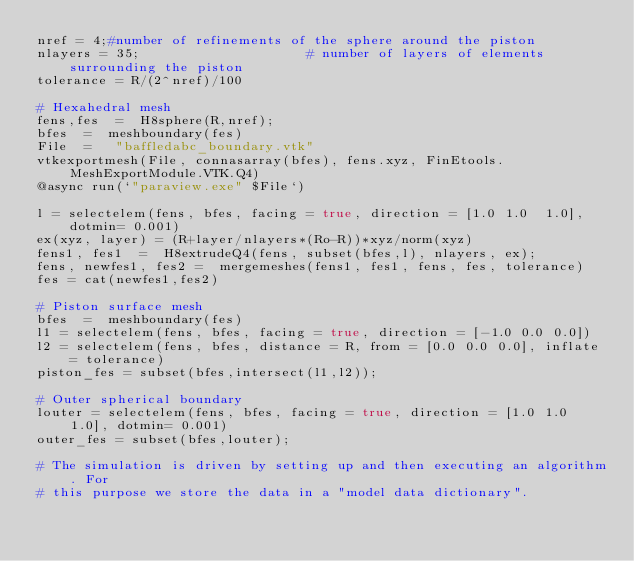<code> <loc_0><loc_0><loc_500><loc_500><_Julia_>nref = 4;#number of refinements of the sphere around the piston
nlayers = 35;                     # number of layers of elements surrounding the piston
tolerance = R/(2^nref)/100
    
# Hexahedral mesh
fens,fes  =  H8sphere(R,nref);
bfes  =  meshboundary(fes)
File  =   "baffledabc_boundary.vtk"
vtkexportmesh(File, connasarray(bfes), fens.xyz, FinEtools.MeshExportModule.VTK.Q4)
@async run(`"paraview.exe" $File`)

l = selectelem(fens, bfes, facing = true, direction = [1.0 1.0  1.0], dotmin= 0.001)
ex(xyz, layer) = (R+layer/nlayers*(Ro-R))*xyz/norm(xyz)
fens1, fes1  =  H8extrudeQ4(fens, subset(bfes,l), nlayers, ex);
fens, newfes1, fes2 =  mergemeshes(fens1, fes1, fens, fes, tolerance)
fes = cat(newfes1,fes2)

# Piston surface mesh
bfes  =  meshboundary(fes)
l1 = selectelem(fens, bfes, facing = true, direction = [-1.0 0.0 0.0])
l2 = selectelem(fens, bfes, distance = R, from = [0.0 0.0 0.0], inflate = tolerance)
piston_fes = subset(bfes,intersect(l1,l2));

# Outer spherical boundary
louter = selectelem(fens, bfes, facing = true, direction = [1.0 1.0  1.0], dotmin= 0.001)
outer_fes = subset(bfes,louter);

# The simulation is driven by setting up and then executing an algorithm. For
# this purpose we store the data in a "model data dictionary".
</code> 